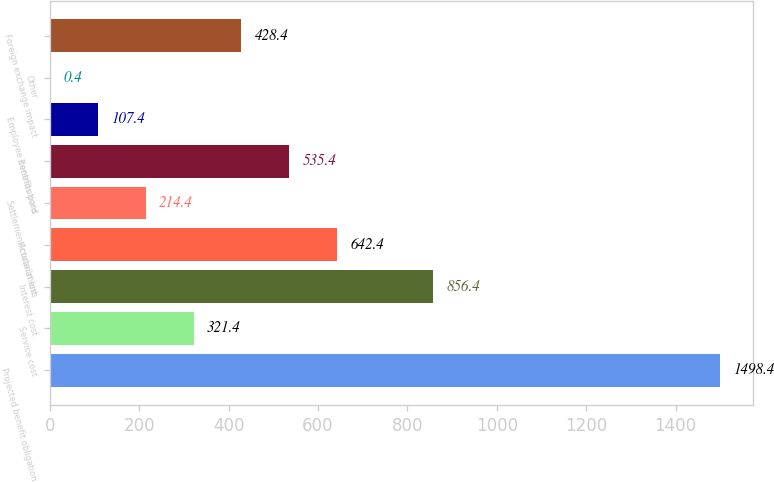Convert chart. <chart><loc_0><loc_0><loc_500><loc_500><bar_chart><fcel>Projected benefit obligation<fcel>Service cost<fcel>Interest cost<fcel>Actuarial loss<fcel>Settlement/curtailment<fcel>Benefits paid<fcel>Employee contributions<fcel>Other<fcel>Foreign exchange impact<nl><fcel>1498.4<fcel>321.4<fcel>856.4<fcel>642.4<fcel>214.4<fcel>535.4<fcel>107.4<fcel>0.4<fcel>428.4<nl></chart> 